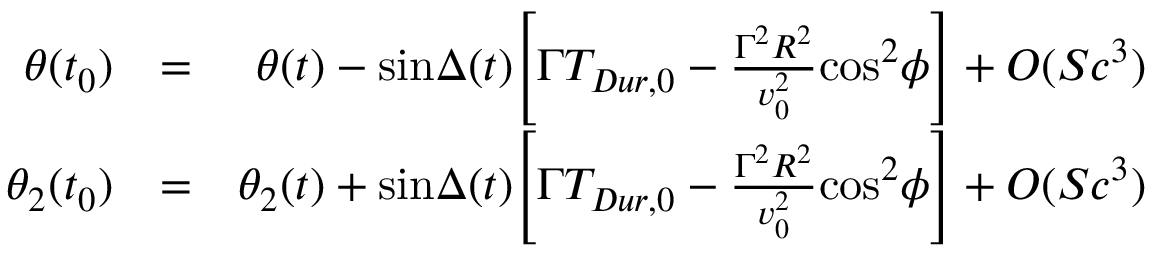Convert formula to latex. <formula><loc_0><loc_0><loc_500><loc_500>\begin{array} { r l r } { \theta ( t _ { 0 } ) } & { = } & { \theta ( t ) - \sin \Delta ( t ) \left [ \Gamma T _ { D u r , 0 } - { \frac { \Gamma ^ { 2 } R ^ { 2 } } { v _ { 0 } ^ { 2 } } } \cos ^ { 2 } \phi \right ] + O ( S c ^ { 3 } ) } \\ { \theta _ { 2 } ( t _ { 0 } ) } & { = } & { \theta _ { 2 } ( t ) + \sin \Delta ( t ) \left [ \Gamma T _ { D u r , 0 } - { \frac { \Gamma ^ { 2 } R ^ { 2 } } { v _ { 0 } ^ { 2 } } } \cos ^ { 2 } \phi \right ] + O ( S c ^ { 3 } ) } \end{array}</formula> 